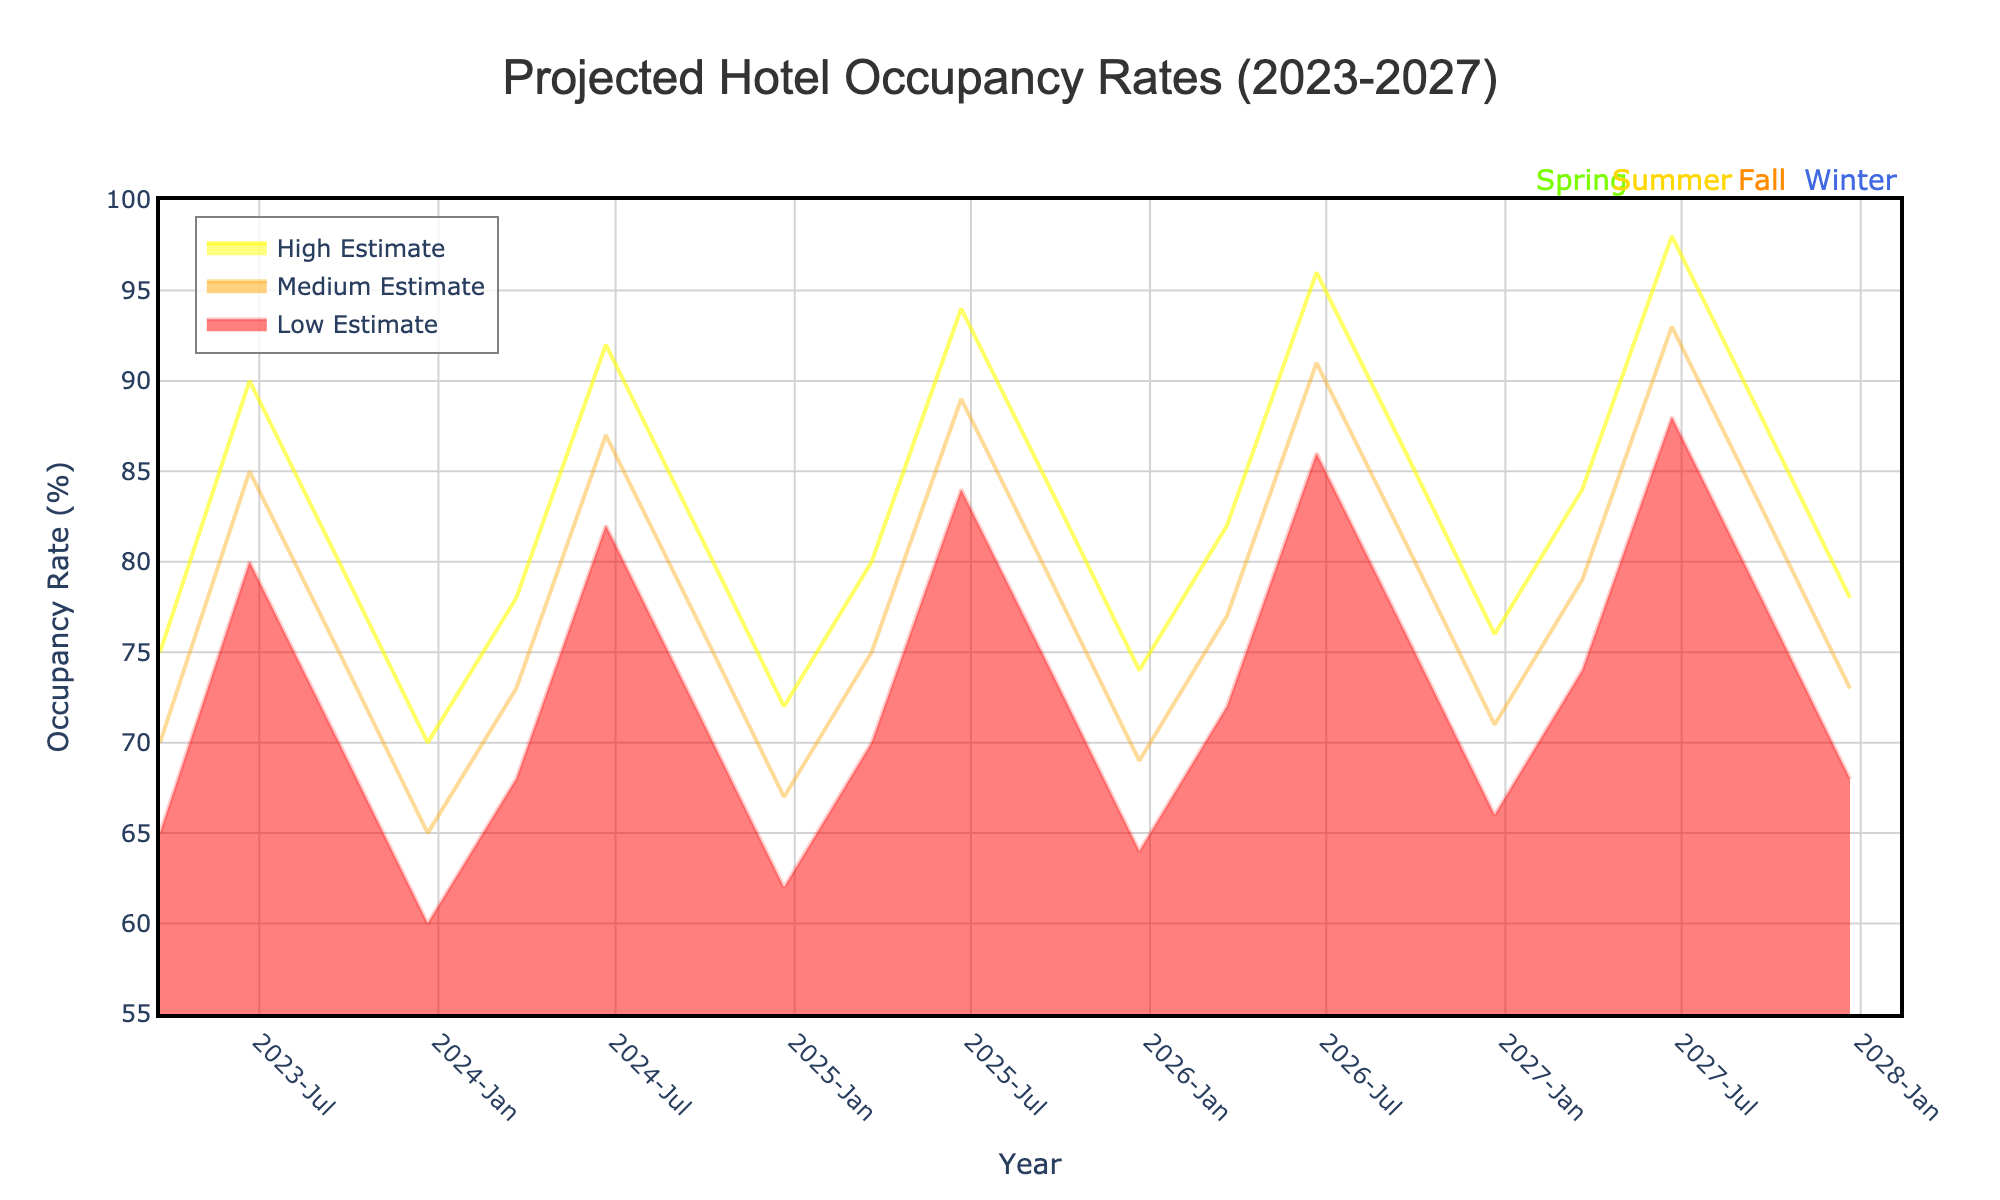What is the title of the figure? The title of the figure is generally located at the top of the chart and gives an overview of the data being presented. In this chart, the title is "Projected Hotel Occupancy Rates (2023-2027).
Answer: Projected Hotel Occupancy Rates (2023-2027) What is the occupancy rate range shown on the y-axis? The y-axis displays the range of occupancy rates, which can be identified by the minimum and maximum values labeled on the y-axis. In this case, the range is from 55% to 100%.
Answer: 55% to 100% Which season has the highest occupancy rate forecasted for each year? To find the season with the highest occupancy rate for each year, we look at the peak points for each year across all estimates. The highest rates are in the summer season, which reaches up to 98% in 2027.
Answer: Summer How does the occupancy rate for Spring 2023 compare to Spring 2027? Compare the estimated occupancy rates for Spring 2023 and Spring 2027 by looking at their points on the chart. For Spring 2023, the range is 65% to 75%, and for Spring 2027, it is 74% to 84%. The occupancy rates have increased.
Answer: Increased What are the projected occupancy rates for Winter 2026? Look for the points representing Winter in 2026 on the x-axis and observe the three lines for low, medium, and high estimates. The projected rates are 66%, 71%, and 76% respectively.
Answer: 66%, 71%, and 76% Is there a visible trend in Summer occupancy rates from 2023 to 2027? Identify the summer seasons from 2023 to 2027 on the x-axis and observe the lines representing the estimates. There is a consistent increase in occupancy rates over the years.
Answer: Increasing trend Which year shows the lowest projected winter occupancy rate? Locate the winter season markers for each year and identify the lowest point among them. Winter 2023 has the lowest projected occupancy rate at 60%-70%.
Answer: Winter 2023 What are the seasonal variations seen in the occupancy rates over the years? To understand seasonal variations, note the fluctuations in occupancy rates across different seasons. Spring and Fall have moderate rates, Winter is consistently the lowest, and Summer has the highest rates.
Answer: Moderate in Spring/Fall, lowest in Winter, highest in Summer Between 2024 and 2026, which season shows the largest increase in its upper estimate? Identify the upper high estimates for each season between 2024 and 2026 and calculate the increases. Summer shows significant growth from 92% in 2024 to 96% in 2026.
Answer: Summer How does the medium estimate for Summer 2025 compare to Fall 2025? Locate the medium estimates for Summer (89%) and Fall (79%) in 2025. Compare these values, showing that Summer's medium estimate is higher.
Answer: Higher 